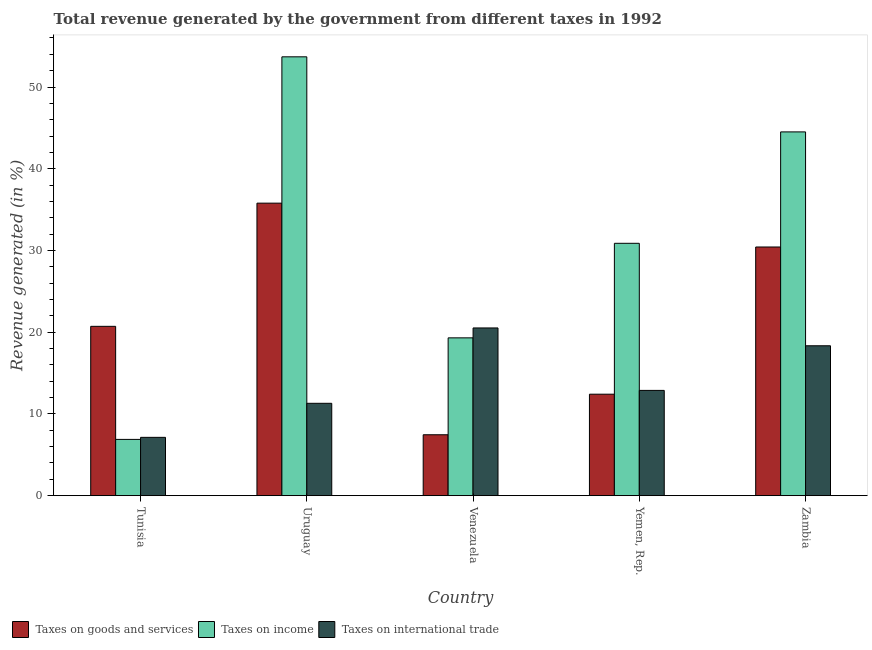How many different coloured bars are there?
Make the answer very short. 3. Are the number of bars per tick equal to the number of legend labels?
Provide a short and direct response. Yes. Are the number of bars on each tick of the X-axis equal?
Offer a very short reply. Yes. How many bars are there on the 3rd tick from the right?
Provide a succinct answer. 3. What is the label of the 3rd group of bars from the left?
Keep it short and to the point. Venezuela. What is the percentage of revenue generated by taxes on income in Yemen, Rep.?
Make the answer very short. 30.88. Across all countries, what is the maximum percentage of revenue generated by taxes on income?
Give a very brief answer. 53.7. Across all countries, what is the minimum percentage of revenue generated by tax on international trade?
Offer a very short reply. 7.14. In which country was the percentage of revenue generated by taxes on goods and services maximum?
Ensure brevity in your answer.  Uruguay. In which country was the percentage of revenue generated by tax on international trade minimum?
Your answer should be very brief. Tunisia. What is the total percentage of revenue generated by taxes on goods and services in the graph?
Your answer should be compact. 106.81. What is the difference between the percentage of revenue generated by tax on international trade in Yemen, Rep. and that in Zambia?
Make the answer very short. -5.46. What is the difference between the percentage of revenue generated by tax on international trade in Venezuela and the percentage of revenue generated by taxes on income in Uruguay?
Keep it short and to the point. -33.17. What is the average percentage of revenue generated by taxes on income per country?
Your answer should be very brief. 31.06. What is the difference between the percentage of revenue generated by tax on international trade and percentage of revenue generated by taxes on goods and services in Tunisia?
Give a very brief answer. -13.58. What is the ratio of the percentage of revenue generated by taxes on goods and services in Venezuela to that in Yemen, Rep.?
Offer a terse response. 0.6. Is the percentage of revenue generated by tax on international trade in Uruguay less than that in Yemen, Rep.?
Offer a terse response. Yes. Is the difference between the percentage of revenue generated by taxes on goods and services in Tunisia and Venezuela greater than the difference between the percentage of revenue generated by tax on international trade in Tunisia and Venezuela?
Offer a very short reply. Yes. What is the difference between the highest and the second highest percentage of revenue generated by taxes on income?
Your answer should be compact. 9.19. What is the difference between the highest and the lowest percentage of revenue generated by taxes on income?
Make the answer very short. 46.81. In how many countries, is the percentage of revenue generated by taxes on income greater than the average percentage of revenue generated by taxes on income taken over all countries?
Your answer should be very brief. 2. What does the 3rd bar from the left in Zambia represents?
Give a very brief answer. Taxes on international trade. What does the 2nd bar from the right in Venezuela represents?
Provide a succinct answer. Taxes on income. How many bars are there?
Your answer should be very brief. 15. Are all the bars in the graph horizontal?
Ensure brevity in your answer.  No. What is the difference between two consecutive major ticks on the Y-axis?
Offer a terse response. 10. Are the values on the major ticks of Y-axis written in scientific E-notation?
Ensure brevity in your answer.  No. How many legend labels are there?
Ensure brevity in your answer.  3. What is the title of the graph?
Ensure brevity in your answer.  Total revenue generated by the government from different taxes in 1992. Does "Liquid fuel" appear as one of the legend labels in the graph?
Make the answer very short. No. What is the label or title of the Y-axis?
Offer a terse response. Revenue generated (in %). What is the Revenue generated (in %) in Taxes on goods and services in Tunisia?
Provide a short and direct response. 20.72. What is the Revenue generated (in %) in Taxes on income in Tunisia?
Offer a very short reply. 6.89. What is the Revenue generated (in %) in Taxes on international trade in Tunisia?
Offer a very short reply. 7.14. What is the Revenue generated (in %) in Taxes on goods and services in Uruguay?
Offer a very short reply. 35.79. What is the Revenue generated (in %) in Taxes on income in Uruguay?
Offer a terse response. 53.7. What is the Revenue generated (in %) in Taxes on international trade in Uruguay?
Your answer should be compact. 11.3. What is the Revenue generated (in %) in Taxes on goods and services in Venezuela?
Your answer should be very brief. 7.45. What is the Revenue generated (in %) in Taxes on income in Venezuela?
Your response must be concise. 19.31. What is the Revenue generated (in %) in Taxes on international trade in Venezuela?
Your response must be concise. 20.52. What is the Revenue generated (in %) of Taxes on goods and services in Yemen, Rep.?
Your answer should be very brief. 12.42. What is the Revenue generated (in %) in Taxes on income in Yemen, Rep.?
Your answer should be very brief. 30.88. What is the Revenue generated (in %) in Taxes on international trade in Yemen, Rep.?
Your answer should be compact. 12.88. What is the Revenue generated (in %) of Taxes on goods and services in Zambia?
Keep it short and to the point. 30.43. What is the Revenue generated (in %) of Taxes on income in Zambia?
Your answer should be very brief. 44.51. What is the Revenue generated (in %) of Taxes on international trade in Zambia?
Your response must be concise. 18.34. Across all countries, what is the maximum Revenue generated (in %) of Taxes on goods and services?
Give a very brief answer. 35.79. Across all countries, what is the maximum Revenue generated (in %) of Taxes on income?
Give a very brief answer. 53.7. Across all countries, what is the maximum Revenue generated (in %) in Taxes on international trade?
Provide a short and direct response. 20.52. Across all countries, what is the minimum Revenue generated (in %) of Taxes on goods and services?
Your answer should be compact. 7.45. Across all countries, what is the minimum Revenue generated (in %) in Taxes on income?
Keep it short and to the point. 6.89. Across all countries, what is the minimum Revenue generated (in %) in Taxes on international trade?
Offer a terse response. 7.14. What is the total Revenue generated (in %) in Taxes on goods and services in the graph?
Offer a very short reply. 106.81. What is the total Revenue generated (in %) of Taxes on income in the graph?
Keep it short and to the point. 155.28. What is the total Revenue generated (in %) in Taxes on international trade in the graph?
Your answer should be very brief. 70.19. What is the difference between the Revenue generated (in %) of Taxes on goods and services in Tunisia and that in Uruguay?
Offer a very short reply. -15.07. What is the difference between the Revenue generated (in %) in Taxes on income in Tunisia and that in Uruguay?
Give a very brief answer. -46.81. What is the difference between the Revenue generated (in %) in Taxes on international trade in Tunisia and that in Uruguay?
Keep it short and to the point. -4.17. What is the difference between the Revenue generated (in %) in Taxes on goods and services in Tunisia and that in Venezuela?
Give a very brief answer. 13.27. What is the difference between the Revenue generated (in %) of Taxes on income in Tunisia and that in Venezuela?
Offer a very short reply. -12.42. What is the difference between the Revenue generated (in %) in Taxes on international trade in Tunisia and that in Venezuela?
Your answer should be very brief. -13.39. What is the difference between the Revenue generated (in %) of Taxes on goods and services in Tunisia and that in Yemen, Rep.?
Ensure brevity in your answer.  8.3. What is the difference between the Revenue generated (in %) in Taxes on income in Tunisia and that in Yemen, Rep.?
Keep it short and to the point. -23.99. What is the difference between the Revenue generated (in %) in Taxes on international trade in Tunisia and that in Yemen, Rep.?
Keep it short and to the point. -5.74. What is the difference between the Revenue generated (in %) in Taxes on goods and services in Tunisia and that in Zambia?
Your response must be concise. -9.71. What is the difference between the Revenue generated (in %) of Taxes on income in Tunisia and that in Zambia?
Offer a terse response. -37.62. What is the difference between the Revenue generated (in %) of Taxes on international trade in Tunisia and that in Zambia?
Your response must be concise. -11.21. What is the difference between the Revenue generated (in %) of Taxes on goods and services in Uruguay and that in Venezuela?
Make the answer very short. 28.34. What is the difference between the Revenue generated (in %) of Taxes on income in Uruguay and that in Venezuela?
Your answer should be compact. 34.39. What is the difference between the Revenue generated (in %) in Taxes on international trade in Uruguay and that in Venezuela?
Ensure brevity in your answer.  -9.22. What is the difference between the Revenue generated (in %) in Taxes on goods and services in Uruguay and that in Yemen, Rep.?
Keep it short and to the point. 23.37. What is the difference between the Revenue generated (in %) of Taxes on income in Uruguay and that in Yemen, Rep.?
Give a very brief answer. 22.82. What is the difference between the Revenue generated (in %) of Taxes on international trade in Uruguay and that in Yemen, Rep.?
Offer a terse response. -1.58. What is the difference between the Revenue generated (in %) of Taxes on goods and services in Uruguay and that in Zambia?
Your answer should be very brief. 5.37. What is the difference between the Revenue generated (in %) in Taxes on income in Uruguay and that in Zambia?
Provide a short and direct response. 9.19. What is the difference between the Revenue generated (in %) of Taxes on international trade in Uruguay and that in Zambia?
Your answer should be very brief. -7.04. What is the difference between the Revenue generated (in %) in Taxes on goods and services in Venezuela and that in Yemen, Rep.?
Keep it short and to the point. -4.96. What is the difference between the Revenue generated (in %) of Taxes on income in Venezuela and that in Yemen, Rep.?
Your answer should be compact. -11.57. What is the difference between the Revenue generated (in %) in Taxes on international trade in Venezuela and that in Yemen, Rep.?
Ensure brevity in your answer.  7.64. What is the difference between the Revenue generated (in %) of Taxes on goods and services in Venezuela and that in Zambia?
Offer a very short reply. -22.97. What is the difference between the Revenue generated (in %) in Taxes on income in Venezuela and that in Zambia?
Ensure brevity in your answer.  -25.2. What is the difference between the Revenue generated (in %) of Taxes on international trade in Venezuela and that in Zambia?
Provide a short and direct response. 2.18. What is the difference between the Revenue generated (in %) of Taxes on goods and services in Yemen, Rep. and that in Zambia?
Ensure brevity in your answer.  -18.01. What is the difference between the Revenue generated (in %) in Taxes on income in Yemen, Rep. and that in Zambia?
Provide a succinct answer. -13.63. What is the difference between the Revenue generated (in %) in Taxes on international trade in Yemen, Rep. and that in Zambia?
Provide a short and direct response. -5.46. What is the difference between the Revenue generated (in %) in Taxes on goods and services in Tunisia and the Revenue generated (in %) in Taxes on income in Uruguay?
Provide a succinct answer. -32.98. What is the difference between the Revenue generated (in %) in Taxes on goods and services in Tunisia and the Revenue generated (in %) in Taxes on international trade in Uruguay?
Give a very brief answer. 9.42. What is the difference between the Revenue generated (in %) in Taxes on income in Tunisia and the Revenue generated (in %) in Taxes on international trade in Uruguay?
Your answer should be compact. -4.42. What is the difference between the Revenue generated (in %) in Taxes on goods and services in Tunisia and the Revenue generated (in %) in Taxes on income in Venezuela?
Provide a succinct answer. 1.41. What is the difference between the Revenue generated (in %) of Taxes on goods and services in Tunisia and the Revenue generated (in %) of Taxes on international trade in Venezuela?
Provide a succinct answer. 0.2. What is the difference between the Revenue generated (in %) in Taxes on income in Tunisia and the Revenue generated (in %) in Taxes on international trade in Venezuela?
Your answer should be compact. -13.64. What is the difference between the Revenue generated (in %) in Taxes on goods and services in Tunisia and the Revenue generated (in %) in Taxes on income in Yemen, Rep.?
Provide a succinct answer. -10.16. What is the difference between the Revenue generated (in %) of Taxes on goods and services in Tunisia and the Revenue generated (in %) of Taxes on international trade in Yemen, Rep.?
Offer a very short reply. 7.84. What is the difference between the Revenue generated (in %) of Taxes on income in Tunisia and the Revenue generated (in %) of Taxes on international trade in Yemen, Rep.?
Your answer should be very brief. -5.99. What is the difference between the Revenue generated (in %) in Taxes on goods and services in Tunisia and the Revenue generated (in %) in Taxes on income in Zambia?
Offer a very short reply. -23.79. What is the difference between the Revenue generated (in %) of Taxes on goods and services in Tunisia and the Revenue generated (in %) of Taxes on international trade in Zambia?
Offer a terse response. 2.38. What is the difference between the Revenue generated (in %) of Taxes on income in Tunisia and the Revenue generated (in %) of Taxes on international trade in Zambia?
Your response must be concise. -11.46. What is the difference between the Revenue generated (in %) in Taxes on goods and services in Uruguay and the Revenue generated (in %) in Taxes on income in Venezuela?
Keep it short and to the point. 16.48. What is the difference between the Revenue generated (in %) in Taxes on goods and services in Uruguay and the Revenue generated (in %) in Taxes on international trade in Venezuela?
Your answer should be compact. 15.27. What is the difference between the Revenue generated (in %) of Taxes on income in Uruguay and the Revenue generated (in %) of Taxes on international trade in Venezuela?
Offer a very short reply. 33.17. What is the difference between the Revenue generated (in %) in Taxes on goods and services in Uruguay and the Revenue generated (in %) in Taxes on income in Yemen, Rep.?
Your answer should be compact. 4.91. What is the difference between the Revenue generated (in %) in Taxes on goods and services in Uruguay and the Revenue generated (in %) in Taxes on international trade in Yemen, Rep.?
Your response must be concise. 22.91. What is the difference between the Revenue generated (in %) in Taxes on income in Uruguay and the Revenue generated (in %) in Taxes on international trade in Yemen, Rep.?
Offer a terse response. 40.82. What is the difference between the Revenue generated (in %) in Taxes on goods and services in Uruguay and the Revenue generated (in %) in Taxes on income in Zambia?
Your answer should be compact. -8.72. What is the difference between the Revenue generated (in %) of Taxes on goods and services in Uruguay and the Revenue generated (in %) of Taxes on international trade in Zambia?
Your answer should be very brief. 17.45. What is the difference between the Revenue generated (in %) of Taxes on income in Uruguay and the Revenue generated (in %) of Taxes on international trade in Zambia?
Your answer should be very brief. 35.35. What is the difference between the Revenue generated (in %) of Taxes on goods and services in Venezuela and the Revenue generated (in %) of Taxes on income in Yemen, Rep.?
Ensure brevity in your answer.  -23.42. What is the difference between the Revenue generated (in %) of Taxes on goods and services in Venezuela and the Revenue generated (in %) of Taxes on international trade in Yemen, Rep.?
Keep it short and to the point. -5.43. What is the difference between the Revenue generated (in %) of Taxes on income in Venezuela and the Revenue generated (in %) of Taxes on international trade in Yemen, Rep.?
Give a very brief answer. 6.43. What is the difference between the Revenue generated (in %) of Taxes on goods and services in Venezuela and the Revenue generated (in %) of Taxes on income in Zambia?
Ensure brevity in your answer.  -37.06. What is the difference between the Revenue generated (in %) of Taxes on goods and services in Venezuela and the Revenue generated (in %) of Taxes on international trade in Zambia?
Offer a very short reply. -10.89. What is the difference between the Revenue generated (in %) of Taxes on income in Venezuela and the Revenue generated (in %) of Taxes on international trade in Zambia?
Offer a terse response. 0.97. What is the difference between the Revenue generated (in %) in Taxes on goods and services in Yemen, Rep. and the Revenue generated (in %) in Taxes on income in Zambia?
Ensure brevity in your answer.  -32.09. What is the difference between the Revenue generated (in %) of Taxes on goods and services in Yemen, Rep. and the Revenue generated (in %) of Taxes on international trade in Zambia?
Your response must be concise. -5.93. What is the difference between the Revenue generated (in %) of Taxes on income in Yemen, Rep. and the Revenue generated (in %) of Taxes on international trade in Zambia?
Make the answer very short. 12.54. What is the average Revenue generated (in %) in Taxes on goods and services per country?
Offer a terse response. 21.36. What is the average Revenue generated (in %) in Taxes on income per country?
Provide a succinct answer. 31.06. What is the average Revenue generated (in %) in Taxes on international trade per country?
Your answer should be very brief. 14.04. What is the difference between the Revenue generated (in %) of Taxes on goods and services and Revenue generated (in %) of Taxes on income in Tunisia?
Your answer should be compact. 13.83. What is the difference between the Revenue generated (in %) in Taxes on goods and services and Revenue generated (in %) in Taxes on international trade in Tunisia?
Ensure brevity in your answer.  13.58. What is the difference between the Revenue generated (in %) of Taxes on income and Revenue generated (in %) of Taxes on international trade in Tunisia?
Your answer should be very brief. -0.25. What is the difference between the Revenue generated (in %) in Taxes on goods and services and Revenue generated (in %) in Taxes on income in Uruguay?
Your response must be concise. -17.9. What is the difference between the Revenue generated (in %) of Taxes on goods and services and Revenue generated (in %) of Taxes on international trade in Uruguay?
Your response must be concise. 24.49. What is the difference between the Revenue generated (in %) in Taxes on income and Revenue generated (in %) in Taxes on international trade in Uruguay?
Ensure brevity in your answer.  42.39. What is the difference between the Revenue generated (in %) in Taxes on goods and services and Revenue generated (in %) in Taxes on income in Venezuela?
Your answer should be compact. -11.86. What is the difference between the Revenue generated (in %) of Taxes on goods and services and Revenue generated (in %) of Taxes on international trade in Venezuela?
Provide a succinct answer. -13.07. What is the difference between the Revenue generated (in %) in Taxes on income and Revenue generated (in %) in Taxes on international trade in Venezuela?
Your answer should be very brief. -1.21. What is the difference between the Revenue generated (in %) in Taxes on goods and services and Revenue generated (in %) in Taxes on income in Yemen, Rep.?
Ensure brevity in your answer.  -18.46. What is the difference between the Revenue generated (in %) of Taxes on goods and services and Revenue generated (in %) of Taxes on international trade in Yemen, Rep.?
Keep it short and to the point. -0.46. What is the difference between the Revenue generated (in %) in Taxes on income and Revenue generated (in %) in Taxes on international trade in Yemen, Rep.?
Ensure brevity in your answer.  18. What is the difference between the Revenue generated (in %) in Taxes on goods and services and Revenue generated (in %) in Taxes on income in Zambia?
Ensure brevity in your answer.  -14.08. What is the difference between the Revenue generated (in %) of Taxes on goods and services and Revenue generated (in %) of Taxes on international trade in Zambia?
Keep it short and to the point. 12.08. What is the difference between the Revenue generated (in %) of Taxes on income and Revenue generated (in %) of Taxes on international trade in Zambia?
Give a very brief answer. 26.17. What is the ratio of the Revenue generated (in %) of Taxes on goods and services in Tunisia to that in Uruguay?
Give a very brief answer. 0.58. What is the ratio of the Revenue generated (in %) of Taxes on income in Tunisia to that in Uruguay?
Provide a succinct answer. 0.13. What is the ratio of the Revenue generated (in %) of Taxes on international trade in Tunisia to that in Uruguay?
Ensure brevity in your answer.  0.63. What is the ratio of the Revenue generated (in %) in Taxes on goods and services in Tunisia to that in Venezuela?
Provide a short and direct response. 2.78. What is the ratio of the Revenue generated (in %) of Taxes on income in Tunisia to that in Venezuela?
Provide a short and direct response. 0.36. What is the ratio of the Revenue generated (in %) of Taxes on international trade in Tunisia to that in Venezuela?
Your answer should be compact. 0.35. What is the ratio of the Revenue generated (in %) of Taxes on goods and services in Tunisia to that in Yemen, Rep.?
Provide a short and direct response. 1.67. What is the ratio of the Revenue generated (in %) in Taxes on income in Tunisia to that in Yemen, Rep.?
Give a very brief answer. 0.22. What is the ratio of the Revenue generated (in %) of Taxes on international trade in Tunisia to that in Yemen, Rep.?
Offer a terse response. 0.55. What is the ratio of the Revenue generated (in %) in Taxes on goods and services in Tunisia to that in Zambia?
Keep it short and to the point. 0.68. What is the ratio of the Revenue generated (in %) in Taxes on income in Tunisia to that in Zambia?
Provide a succinct answer. 0.15. What is the ratio of the Revenue generated (in %) in Taxes on international trade in Tunisia to that in Zambia?
Your response must be concise. 0.39. What is the ratio of the Revenue generated (in %) of Taxes on goods and services in Uruguay to that in Venezuela?
Offer a terse response. 4.8. What is the ratio of the Revenue generated (in %) in Taxes on income in Uruguay to that in Venezuela?
Offer a terse response. 2.78. What is the ratio of the Revenue generated (in %) in Taxes on international trade in Uruguay to that in Venezuela?
Make the answer very short. 0.55. What is the ratio of the Revenue generated (in %) in Taxes on goods and services in Uruguay to that in Yemen, Rep.?
Provide a succinct answer. 2.88. What is the ratio of the Revenue generated (in %) of Taxes on income in Uruguay to that in Yemen, Rep.?
Your response must be concise. 1.74. What is the ratio of the Revenue generated (in %) of Taxes on international trade in Uruguay to that in Yemen, Rep.?
Offer a terse response. 0.88. What is the ratio of the Revenue generated (in %) of Taxes on goods and services in Uruguay to that in Zambia?
Your answer should be compact. 1.18. What is the ratio of the Revenue generated (in %) in Taxes on income in Uruguay to that in Zambia?
Give a very brief answer. 1.21. What is the ratio of the Revenue generated (in %) in Taxes on international trade in Uruguay to that in Zambia?
Provide a succinct answer. 0.62. What is the ratio of the Revenue generated (in %) in Taxes on goods and services in Venezuela to that in Yemen, Rep.?
Your response must be concise. 0.6. What is the ratio of the Revenue generated (in %) in Taxes on income in Venezuela to that in Yemen, Rep.?
Provide a succinct answer. 0.63. What is the ratio of the Revenue generated (in %) in Taxes on international trade in Venezuela to that in Yemen, Rep.?
Your answer should be compact. 1.59. What is the ratio of the Revenue generated (in %) of Taxes on goods and services in Venezuela to that in Zambia?
Offer a terse response. 0.24. What is the ratio of the Revenue generated (in %) of Taxes on income in Venezuela to that in Zambia?
Provide a succinct answer. 0.43. What is the ratio of the Revenue generated (in %) of Taxes on international trade in Venezuela to that in Zambia?
Provide a short and direct response. 1.12. What is the ratio of the Revenue generated (in %) of Taxes on goods and services in Yemen, Rep. to that in Zambia?
Your response must be concise. 0.41. What is the ratio of the Revenue generated (in %) of Taxes on income in Yemen, Rep. to that in Zambia?
Provide a succinct answer. 0.69. What is the ratio of the Revenue generated (in %) in Taxes on international trade in Yemen, Rep. to that in Zambia?
Your answer should be compact. 0.7. What is the difference between the highest and the second highest Revenue generated (in %) of Taxes on goods and services?
Your answer should be compact. 5.37. What is the difference between the highest and the second highest Revenue generated (in %) of Taxes on income?
Give a very brief answer. 9.19. What is the difference between the highest and the second highest Revenue generated (in %) in Taxes on international trade?
Give a very brief answer. 2.18. What is the difference between the highest and the lowest Revenue generated (in %) of Taxes on goods and services?
Your answer should be very brief. 28.34. What is the difference between the highest and the lowest Revenue generated (in %) of Taxes on income?
Give a very brief answer. 46.81. What is the difference between the highest and the lowest Revenue generated (in %) of Taxes on international trade?
Your answer should be very brief. 13.39. 